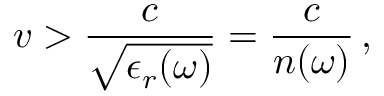Convert formula to latex. <formula><loc_0><loc_0><loc_500><loc_500>v > \frac { c } { \sqrt { \epsilon _ { r } ( \omega ) } } = \frac { c } { n ( \omega ) } \, ,</formula> 